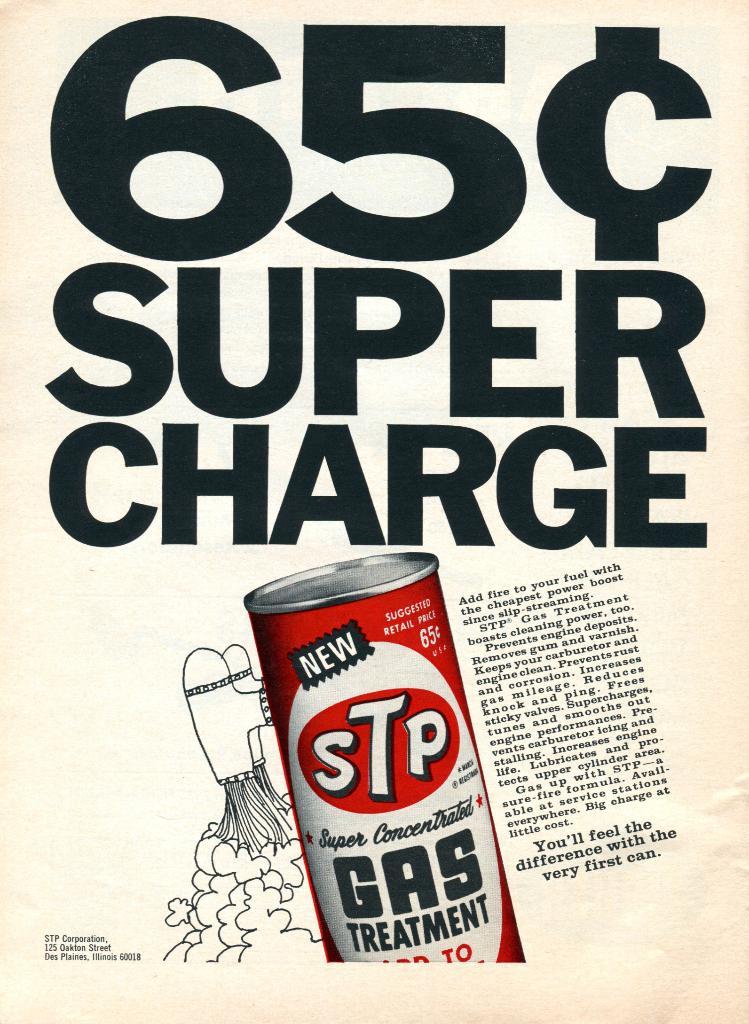How much is a super charge?
Provide a succinct answer. 65 cents. What is the company who makes the product?
Keep it short and to the point. Stp. 